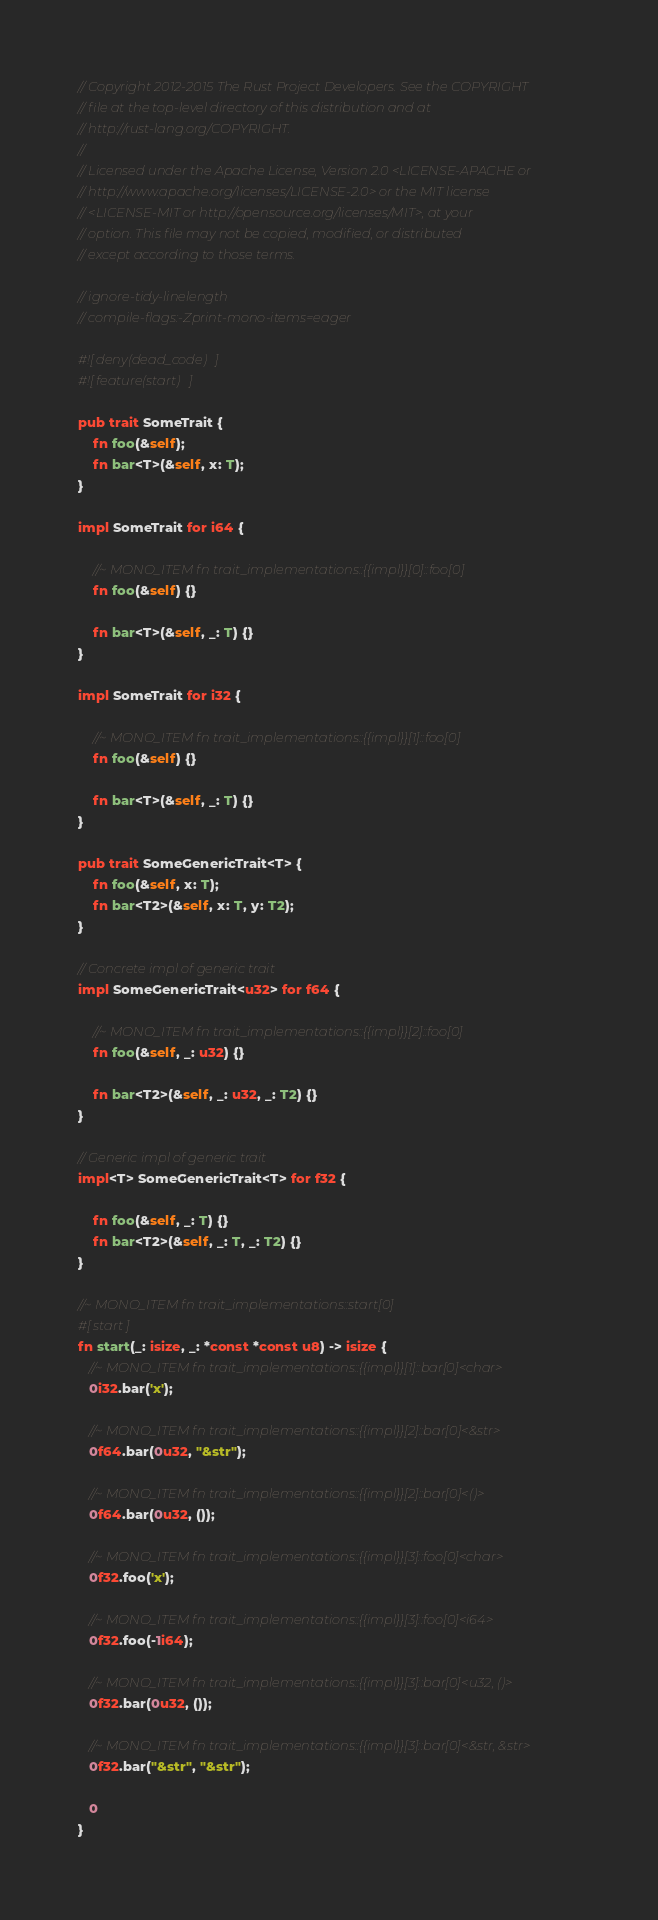Convert code to text. <code><loc_0><loc_0><loc_500><loc_500><_Rust_>// Copyright 2012-2015 The Rust Project Developers. See the COPYRIGHT
// file at the top-level directory of this distribution and at
// http://rust-lang.org/COPYRIGHT.
//
// Licensed under the Apache License, Version 2.0 <LICENSE-APACHE or
// http://www.apache.org/licenses/LICENSE-2.0> or the MIT license
// <LICENSE-MIT or http://opensource.org/licenses/MIT>, at your
// option. This file may not be copied, modified, or distributed
// except according to those terms.

// ignore-tidy-linelength
// compile-flags:-Zprint-mono-items=eager

#![deny(dead_code)]
#![feature(start)]

pub trait SomeTrait {
    fn foo(&self);
    fn bar<T>(&self, x: T);
}

impl SomeTrait for i64 {

    //~ MONO_ITEM fn trait_implementations::{{impl}}[0]::foo[0]
    fn foo(&self) {}

    fn bar<T>(&self, _: T) {}
}

impl SomeTrait for i32 {

    //~ MONO_ITEM fn trait_implementations::{{impl}}[1]::foo[0]
    fn foo(&self) {}

    fn bar<T>(&self, _: T) {}
}

pub trait SomeGenericTrait<T> {
    fn foo(&self, x: T);
    fn bar<T2>(&self, x: T, y: T2);
}

// Concrete impl of generic trait
impl SomeGenericTrait<u32> for f64 {

    //~ MONO_ITEM fn trait_implementations::{{impl}}[2]::foo[0]
    fn foo(&self, _: u32) {}

    fn bar<T2>(&self, _: u32, _: T2) {}
}

// Generic impl of generic trait
impl<T> SomeGenericTrait<T> for f32 {

    fn foo(&self, _: T) {}
    fn bar<T2>(&self, _: T, _: T2) {}
}

//~ MONO_ITEM fn trait_implementations::start[0]
#[start]
fn start(_: isize, _: *const *const u8) -> isize {
   //~ MONO_ITEM fn trait_implementations::{{impl}}[1]::bar[0]<char>
   0i32.bar('x');

   //~ MONO_ITEM fn trait_implementations::{{impl}}[2]::bar[0]<&str>
   0f64.bar(0u32, "&str");

   //~ MONO_ITEM fn trait_implementations::{{impl}}[2]::bar[0]<()>
   0f64.bar(0u32, ());

   //~ MONO_ITEM fn trait_implementations::{{impl}}[3]::foo[0]<char>
   0f32.foo('x');

   //~ MONO_ITEM fn trait_implementations::{{impl}}[3]::foo[0]<i64>
   0f32.foo(-1i64);

   //~ MONO_ITEM fn trait_implementations::{{impl}}[3]::bar[0]<u32, ()>
   0f32.bar(0u32, ());

   //~ MONO_ITEM fn trait_implementations::{{impl}}[3]::bar[0]<&str, &str>
   0f32.bar("&str", "&str");

   0
}
</code> 